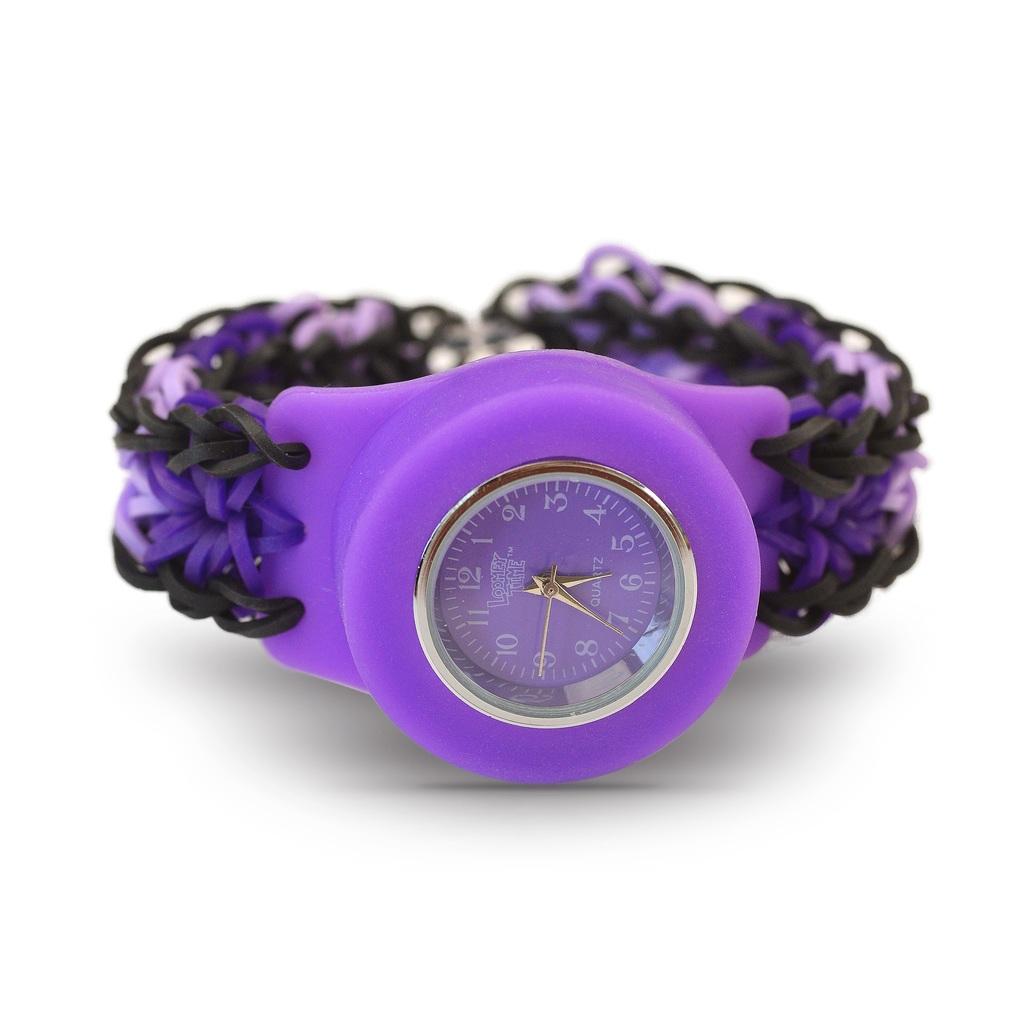What time is shown on this purple watch?
Provide a short and direct response. 5:36. What number is the big hand pointing to?
Give a very brief answer. 7. 